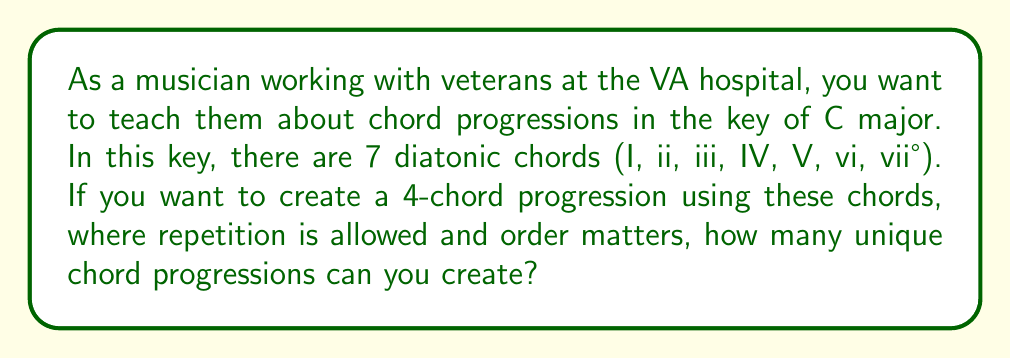Show me your answer to this math problem. To solve this problem, we need to use the concept of permutations with repetition. Here's the step-by-step explanation:

1. We have 7 choices for each position in the 4-chord progression.
2. We can use the same chord multiple times (repetition is allowed).
3. The order of the chords matters (e.g., I-IV-V-I is different from IV-I-V-I).

This scenario fits the formula for permutations with repetition:

$$ n^r $$

Where:
$n$ = number of choices for each position
$r$ = number of positions to be filled

In this case:
$n = 7$ (7 diatonic chords)
$r = 4$ (4-chord progression)

Substituting these values into the formula:

$$ 7^4 = 7 \times 7 \times 7 \times 7 = 2401 $$

Therefore, the number of unique 4-chord progressions in the key of C major, allowing repetition and considering order, is 2401.
Answer: 2401 unique chord progressions 